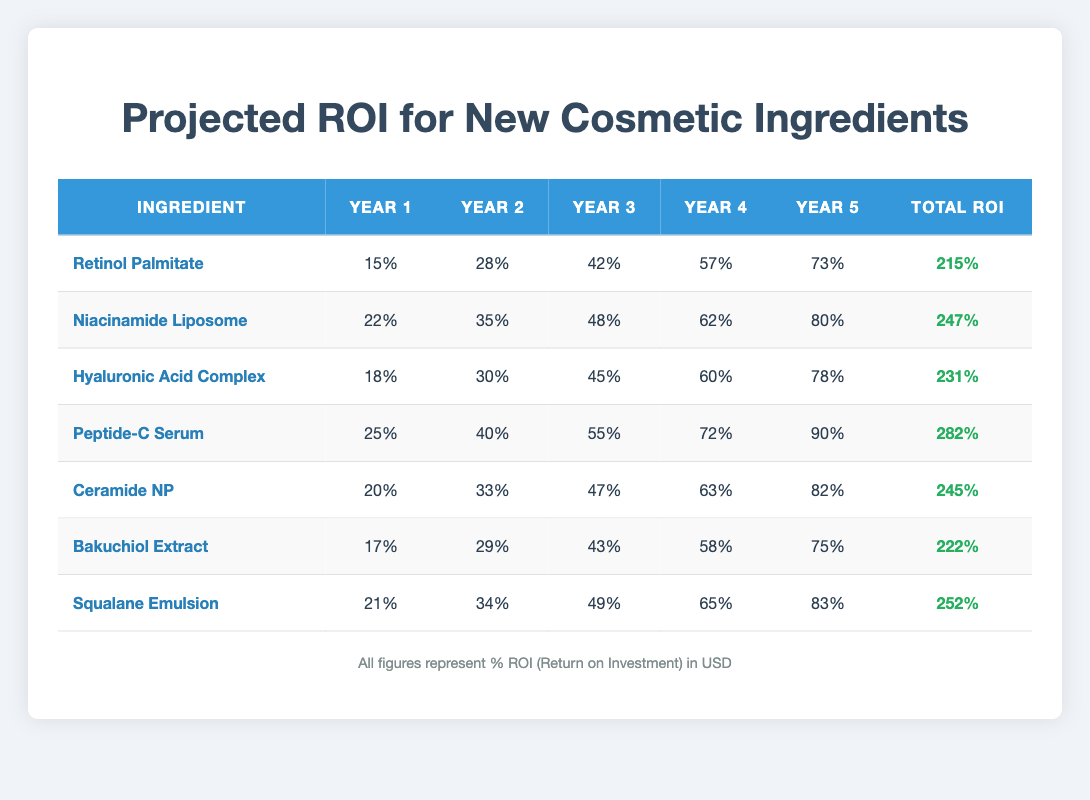What is the total ROI for Peptide-C Serum? Referring to the table, the total ROI for Peptide-C Serum is located in the last column of its row. It states 282%.
Answer: 282% Which ingredient has the highest ROI in Year 3? By comparing the Year 3 values of all ingredients in the table, Peptide-C Serum has the highest ROI at 55%.
Answer: Peptide-C Serum What is the sum of Year 1 ROI for all ingredients? The Year 1 ROI values are: 15, 22, 18, 25, 20, 17, and 21. Adding these gives a total of 15 + 22 + 18 + 25 + 20 + 17 + 21 = 138.
Answer: 138 Is the total ROI for Niacinamide Liposome greater than that of Bakuchiol Extract? The total ROI for Niacinamide Liposome is 247% and for Bakuchiol Extract it is 222%. Since 247% > 222%, the statement is true.
Answer: Yes What is the average ROI for Year 5 across all ingredients? The Year 5 values are: 73, 80, 78, 90, 82, 75, and 83. The sum is 73 + 80 + 78 + 90 + 82 + 75 + 83 = 561. There are 7 ingredients, so the average is 561 / 7 ≈ 80.14.
Answer: 80.14 Which ingredient has the lowest ROI in Year 2 and what is that value? In the Year 2 column, the values are 28, 35, 30, 40, 33, 29, and 34. The lowest value is 28 for Retinol Palmitate.
Answer: Retinol Palmitate, 28% What is the difference in total ROI between Squalane Emulsion and Ceramide NP? The total ROI for Squalane Emulsion is 252% and for Ceramide NP it is 245%. The difference is 252% - 245% = 7%.
Answer: 7% Does the ROI for Hyaluronic Acid Complex in Year 4 exceed 60%? The Year 4 ROI for Hyaluronic Acid Complex is 60%. Since it does not exceed 60%, the statement is false.
Answer: No If we take an average of the Year 1 values and an average of the Year 5 values, does the Year 1 average exceed the Year 5 average? The average for Year 1 is 138 / 7 ≈ 19.714 and for Year 5 is 561 / 7 ≈ 80.14. Since 19.714 < 80.14, the statement is false.
Answer: No 